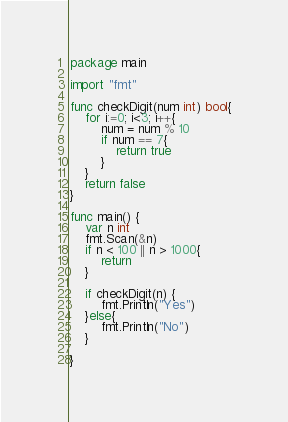Convert code to text. <code><loc_0><loc_0><loc_500><loc_500><_Go_>package main

import "fmt"

func checkDigit(num int) bool{
	for i:=0; i<3; i++{
		num = num % 10
		if num == 7{
			return true
		}
	}
	return false
}

func main() {
	var n int
	fmt.Scan(&n)
	if n < 100 || n > 1000{
		return
	}

	if checkDigit(n) {
		fmt.Println("Yes")
	}else{
		fmt.Println("No")
	}

}</code> 